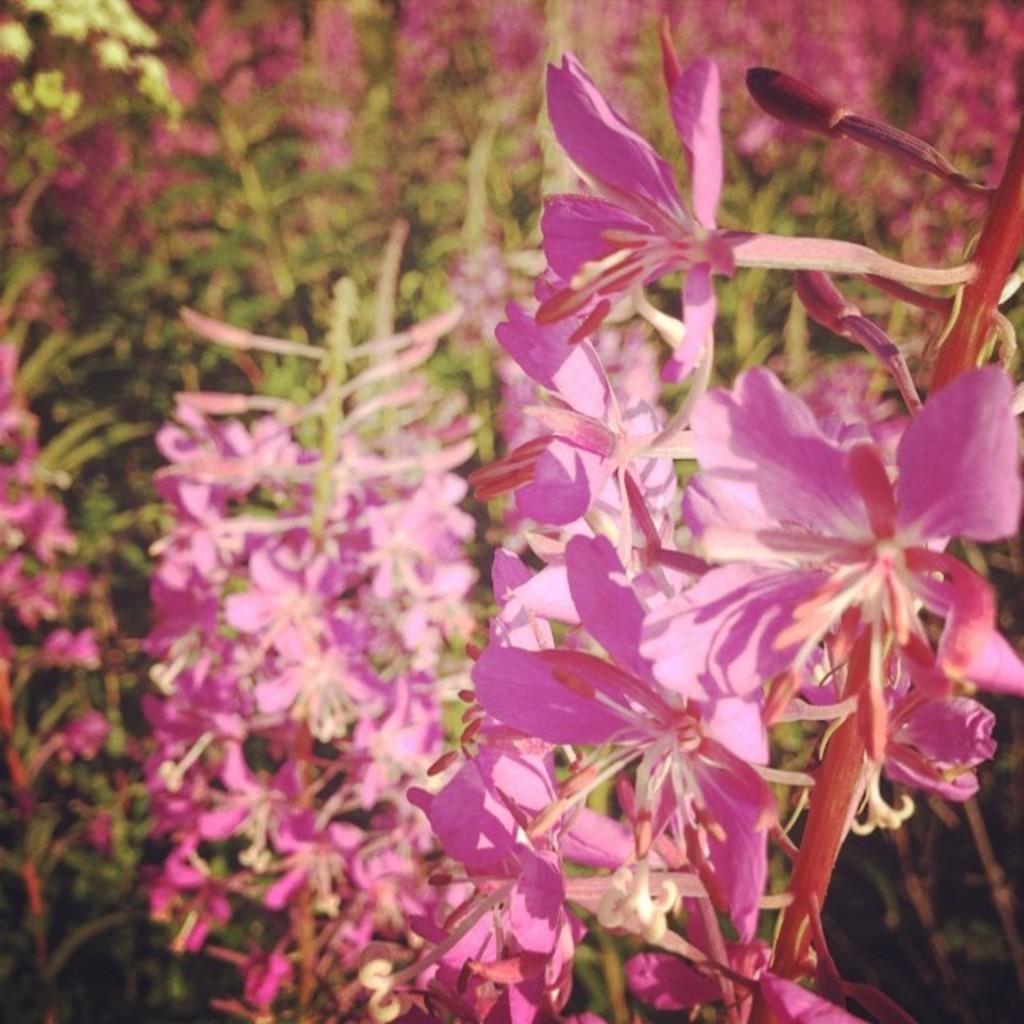Can you describe this image briefly? In the image there is a flower plant with beautiful pink flowers and the background of the plant is blur. 